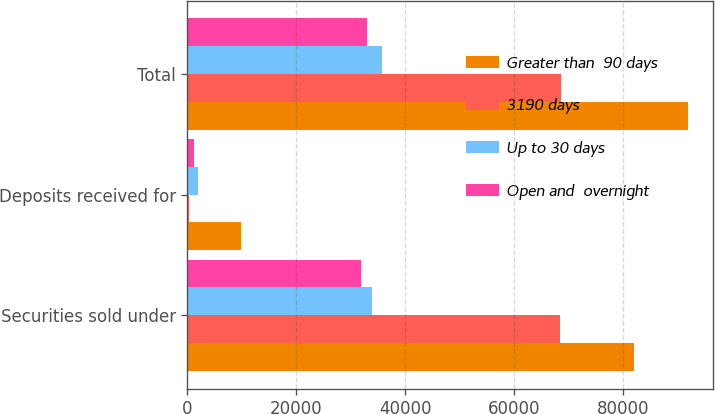Convert chart. <chart><loc_0><loc_0><loc_500><loc_500><stacked_bar_chart><ecel><fcel>Securities sold under<fcel>Deposits received for<fcel>Total<nl><fcel>Greater than  90 days<fcel>82073<fcel>9946<fcel>92019<nl><fcel>3190 days<fcel>68372<fcel>266<fcel>68638<nl><fcel>Up to 30 days<fcel>33846<fcel>1912<fcel>35758<nl><fcel>Open and  overnight<fcel>31831<fcel>1181<fcel>33012<nl></chart> 